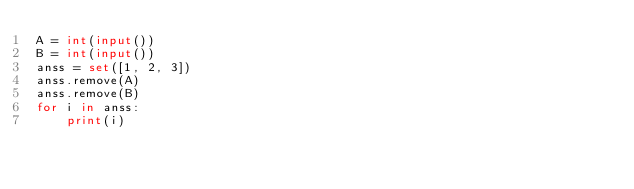<code> <loc_0><loc_0><loc_500><loc_500><_Python_>A = int(input())
B = int(input())
anss = set([1, 2, 3])
anss.remove(A)
anss.remove(B)
for i in anss:
    print(i)
</code> 